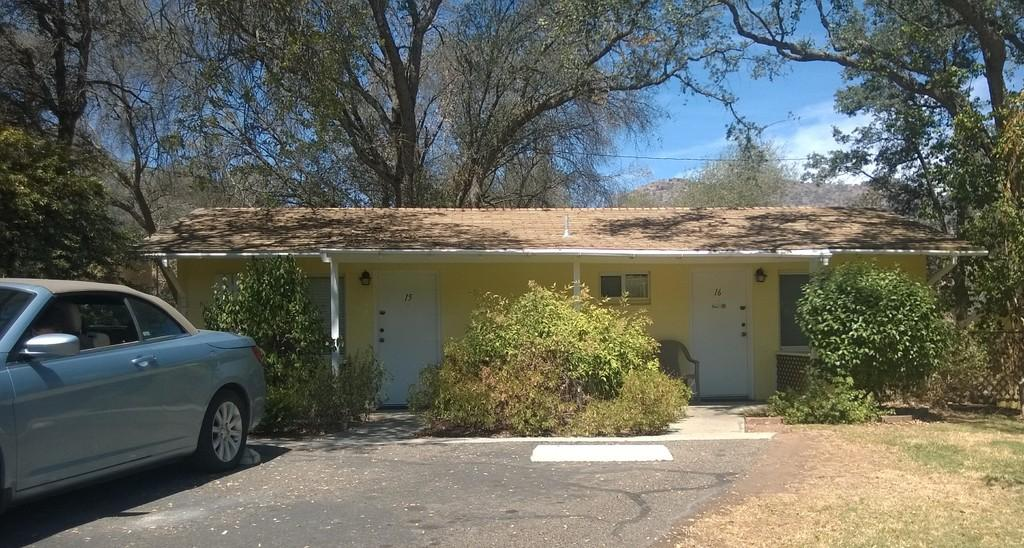What type of living organisms can be seen in the image? Plants are visible in the image. Can you describe the structure in the image? There is a house with doors and boards in the image. What type of furniture is present in the image? There is a chair in the image. What can be seen on the left side of the image? There is a vehicle on the left side of the image. What is visible in the background of the image? Clouds and the sky are visible in the background of the image. How many men are visible in the image? There are no men present in the image. Can you describe the tiger's behavior in the image? There is no tiger present in the image. 